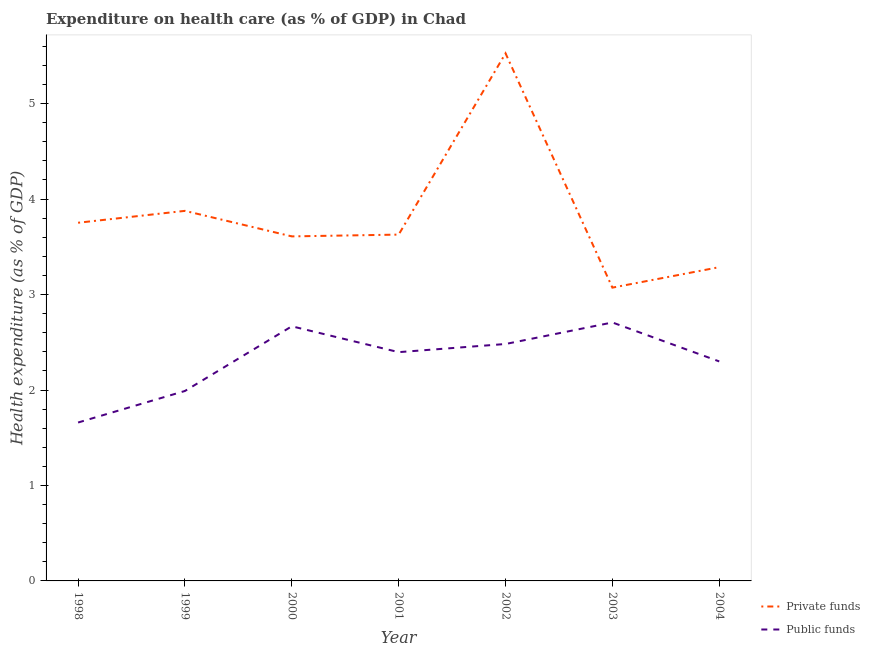Does the line corresponding to amount of private funds spent in healthcare intersect with the line corresponding to amount of public funds spent in healthcare?
Keep it short and to the point. No. What is the amount of private funds spent in healthcare in 2002?
Your response must be concise. 5.53. Across all years, what is the maximum amount of public funds spent in healthcare?
Make the answer very short. 2.71. Across all years, what is the minimum amount of public funds spent in healthcare?
Keep it short and to the point. 1.66. In which year was the amount of public funds spent in healthcare maximum?
Keep it short and to the point. 2003. What is the total amount of private funds spent in healthcare in the graph?
Offer a very short reply. 26.75. What is the difference between the amount of public funds spent in healthcare in 2000 and that in 2002?
Make the answer very short. 0.19. What is the difference between the amount of public funds spent in healthcare in 1999 and the amount of private funds spent in healthcare in 2000?
Your answer should be very brief. -1.62. What is the average amount of public funds spent in healthcare per year?
Your answer should be very brief. 2.31. In the year 1999, what is the difference between the amount of public funds spent in healthcare and amount of private funds spent in healthcare?
Your response must be concise. -1.89. What is the ratio of the amount of public funds spent in healthcare in 1998 to that in 2003?
Keep it short and to the point. 0.61. Is the amount of public funds spent in healthcare in 1999 less than that in 2000?
Your answer should be very brief. Yes. Is the difference between the amount of private funds spent in healthcare in 2002 and 2004 greater than the difference between the amount of public funds spent in healthcare in 2002 and 2004?
Your answer should be very brief. Yes. What is the difference between the highest and the second highest amount of private funds spent in healthcare?
Offer a terse response. 1.65. What is the difference between the highest and the lowest amount of private funds spent in healthcare?
Offer a terse response. 2.45. Is the sum of the amount of private funds spent in healthcare in 1998 and 2002 greater than the maximum amount of public funds spent in healthcare across all years?
Your response must be concise. Yes. Does the amount of public funds spent in healthcare monotonically increase over the years?
Make the answer very short. No. Is the amount of public funds spent in healthcare strictly greater than the amount of private funds spent in healthcare over the years?
Give a very brief answer. No. How many lines are there?
Give a very brief answer. 2. Are the values on the major ticks of Y-axis written in scientific E-notation?
Provide a short and direct response. No. Does the graph contain any zero values?
Provide a short and direct response. No. Does the graph contain grids?
Offer a terse response. No. How many legend labels are there?
Keep it short and to the point. 2. What is the title of the graph?
Offer a very short reply. Expenditure on health care (as % of GDP) in Chad. Does "Not attending school" appear as one of the legend labels in the graph?
Your answer should be compact. No. What is the label or title of the X-axis?
Give a very brief answer. Year. What is the label or title of the Y-axis?
Your answer should be compact. Health expenditure (as % of GDP). What is the Health expenditure (as % of GDP) in Private funds in 1998?
Make the answer very short. 3.75. What is the Health expenditure (as % of GDP) of Public funds in 1998?
Ensure brevity in your answer.  1.66. What is the Health expenditure (as % of GDP) of Private funds in 1999?
Ensure brevity in your answer.  3.88. What is the Health expenditure (as % of GDP) in Public funds in 1999?
Your answer should be compact. 1.99. What is the Health expenditure (as % of GDP) of Private funds in 2000?
Your answer should be compact. 3.61. What is the Health expenditure (as % of GDP) in Public funds in 2000?
Your response must be concise. 2.67. What is the Health expenditure (as % of GDP) in Private funds in 2001?
Keep it short and to the point. 3.63. What is the Health expenditure (as % of GDP) of Public funds in 2001?
Offer a very short reply. 2.4. What is the Health expenditure (as % of GDP) in Private funds in 2002?
Ensure brevity in your answer.  5.53. What is the Health expenditure (as % of GDP) in Public funds in 2002?
Provide a short and direct response. 2.48. What is the Health expenditure (as % of GDP) in Private funds in 2003?
Provide a succinct answer. 3.07. What is the Health expenditure (as % of GDP) in Public funds in 2003?
Make the answer very short. 2.71. What is the Health expenditure (as % of GDP) of Private funds in 2004?
Your response must be concise. 3.29. What is the Health expenditure (as % of GDP) of Public funds in 2004?
Offer a terse response. 2.3. Across all years, what is the maximum Health expenditure (as % of GDP) in Private funds?
Provide a succinct answer. 5.53. Across all years, what is the maximum Health expenditure (as % of GDP) of Public funds?
Your answer should be compact. 2.71. Across all years, what is the minimum Health expenditure (as % of GDP) in Private funds?
Offer a very short reply. 3.07. Across all years, what is the minimum Health expenditure (as % of GDP) of Public funds?
Ensure brevity in your answer.  1.66. What is the total Health expenditure (as % of GDP) of Private funds in the graph?
Provide a short and direct response. 26.75. What is the total Health expenditure (as % of GDP) of Public funds in the graph?
Your answer should be very brief. 16.2. What is the difference between the Health expenditure (as % of GDP) of Private funds in 1998 and that in 1999?
Keep it short and to the point. -0.12. What is the difference between the Health expenditure (as % of GDP) in Public funds in 1998 and that in 1999?
Your answer should be compact. -0.33. What is the difference between the Health expenditure (as % of GDP) of Private funds in 1998 and that in 2000?
Your response must be concise. 0.14. What is the difference between the Health expenditure (as % of GDP) in Public funds in 1998 and that in 2000?
Your answer should be compact. -1.01. What is the difference between the Health expenditure (as % of GDP) of Private funds in 1998 and that in 2001?
Your answer should be compact. 0.12. What is the difference between the Health expenditure (as % of GDP) in Public funds in 1998 and that in 2001?
Provide a succinct answer. -0.74. What is the difference between the Health expenditure (as % of GDP) in Private funds in 1998 and that in 2002?
Provide a succinct answer. -1.77. What is the difference between the Health expenditure (as % of GDP) in Public funds in 1998 and that in 2002?
Ensure brevity in your answer.  -0.82. What is the difference between the Health expenditure (as % of GDP) in Private funds in 1998 and that in 2003?
Make the answer very short. 0.68. What is the difference between the Health expenditure (as % of GDP) in Public funds in 1998 and that in 2003?
Give a very brief answer. -1.05. What is the difference between the Health expenditure (as % of GDP) in Private funds in 1998 and that in 2004?
Ensure brevity in your answer.  0.47. What is the difference between the Health expenditure (as % of GDP) of Public funds in 1998 and that in 2004?
Provide a succinct answer. -0.64. What is the difference between the Health expenditure (as % of GDP) in Private funds in 1999 and that in 2000?
Your answer should be compact. 0.27. What is the difference between the Health expenditure (as % of GDP) of Public funds in 1999 and that in 2000?
Offer a terse response. -0.68. What is the difference between the Health expenditure (as % of GDP) of Private funds in 1999 and that in 2001?
Provide a succinct answer. 0.25. What is the difference between the Health expenditure (as % of GDP) in Public funds in 1999 and that in 2001?
Provide a short and direct response. -0.41. What is the difference between the Health expenditure (as % of GDP) in Private funds in 1999 and that in 2002?
Keep it short and to the point. -1.65. What is the difference between the Health expenditure (as % of GDP) of Public funds in 1999 and that in 2002?
Offer a very short reply. -0.49. What is the difference between the Health expenditure (as % of GDP) of Private funds in 1999 and that in 2003?
Keep it short and to the point. 0.8. What is the difference between the Health expenditure (as % of GDP) of Public funds in 1999 and that in 2003?
Your response must be concise. -0.72. What is the difference between the Health expenditure (as % of GDP) in Private funds in 1999 and that in 2004?
Your answer should be compact. 0.59. What is the difference between the Health expenditure (as % of GDP) of Public funds in 1999 and that in 2004?
Your answer should be very brief. -0.31. What is the difference between the Health expenditure (as % of GDP) of Private funds in 2000 and that in 2001?
Give a very brief answer. -0.02. What is the difference between the Health expenditure (as % of GDP) of Public funds in 2000 and that in 2001?
Your answer should be compact. 0.27. What is the difference between the Health expenditure (as % of GDP) of Private funds in 2000 and that in 2002?
Offer a very short reply. -1.92. What is the difference between the Health expenditure (as % of GDP) of Public funds in 2000 and that in 2002?
Keep it short and to the point. 0.19. What is the difference between the Health expenditure (as % of GDP) in Private funds in 2000 and that in 2003?
Provide a short and direct response. 0.54. What is the difference between the Health expenditure (as % of GDP) in Public funds in 2000 and that in 2003?
Offer a terse response. -0.04. What is the difference between the Health expenditure (as % of GDP) of Private funds in 2000 and that in 2004?
Your answer should be very brief. 0.32. What is the difference between the Health expenditure (as % of GDP) of Public funds in 2000 and that in 2004?
Offer a terse response. 0.37. What is the difference between the Health expenditure (as % of GDP) in Private funds in 2001 and that in 2002?
Give a very brief answer. -1.9. What is the difference between the Health expenditure (as % of GDP) of Public funds in 2001 and that in 2002?
Your answer should be very brief. -0.09. What is the difference between the Health expenditure (as % of GDP) in Private funds in 2001 and that in 2003?
Your response must be concise. 0.56. What is the difference between the Health expenditure (as % of GDP) of Public funds in 2001 and that in 2003?
Keep it short and to the point. -0.31. What is the difference between the Health expenditure (as % of GDP) of Private funds in 2001 and that in 2004?
Keep it short and to the point. 0.34. What is the difference between the Health expenditure (as % of GDP) in Public funds in 2001 and that in 2004?
Your response must be concise. 0.1. What is the difference between the Health expenditure (as % of GDP) in Private funds in 2002 and that in 2003?
Keep it short and to the point. 2.45. What is the difference between the Health expenditure (as % of GDP) in Public funds in 2002 and that in 2003?
Give a very brief answer. -0.23. What is the difference between the Health expenditure (as % of GDP) in Private funds in 2002 and that in 2004?
Ensure brevity in your answer.  2.24. What is the difference between the Health expenditure (as % of GDP) of Public funds in 2002 and that in 2004?
Provide a short and direct response. 0.18. What is the difference between the Health expenditure (as % of GDP) in Private funds in 2003 and that in 2004?
Offer a terse response. -0.21. What is the difference between the Health expenditure (as % of GDP) in Public funds in 2003 and that in 2004?
Offer a terse response. 0.41. What is the difference between the Health expenditure (as % of GDP) of Private funds in 1998 and the Health expenditure (as % of GDP) of Public funds in 1999?
Ensure brevity in your answer.  1.76. What is the difference between the Health expenditure (as % of GDP) in Private funds in 1998 and the Health expenditure (as % of GDP) in Public funds in 2000?
Make the answer very short. 1.08. What is the difference between the Health expenditure (as % of GDP) in Private funds in 1998 and the Health expenditure (as % of GDP) in Public funds in 2001?
Your answer should be very brief. 1.36. What is the difference between the Health expenditure (as % of GDP) in Private funds in 1998 and the Health expenditure (as % of GDP) in Public funds in 2002?
Provide a short and direct response. 1.27. What is the difference between the Health expenditure (as % of GDP) of Private funds in 1998 and the Health expenditure (as % of GDP) of Public funds in 2003?
Your response must be concise. 1.04. What is the difference between the Health expenditure (as % of GDP) of Private funds in 1998 and the Health expenditure (as % of GDP) of Public funds in 2004?
Give a very brief answer. 1.45. What is the difference between the Health expenditure (as % of GDP) in Private funds in 1999 and the Health expenditure (as % of GDP) in Public funds in 2000?
Ensure brevity in your answer.  1.21. What is the difference between the Health expenditure (as % of GDP) of Private funds in 1999 and the Health expenditure (as % of GDP) of Public funds in 2001?
Your answer should be compact. 1.48. What is the difference between the Health expenditure (as % of GDP) of Private funds in 1999 and the Health expenditure (as % of GDP) of Public funds in 2002?
Offer a terse response. 1.39. What is the difference between the Health expenditure (as % of GDP) of Private funds in 1999 and the Health expenditure (as % of GDP) of Public funds in 2003?
Offer a very short reply. 1.17. What is the difference between the Health expenditure (as % of GDP) of Private funds in 1999 and the Health expenditure (as % of GDP) of Public funds in 2004?
Make the answer very short. 1.58. What is the difference between the Health expenditure (as % of GDP) of Private funds in 2000 and the Health expenditure (as % of GDP) of Public funds in 2001?
Ensure brevity in your answer.  1.21. What is the difference between the Health expenditure (as % of GDP) of Private funds in 2000 and the Health expenditure (as % of GDP) of Public funds in 2002?
Make the answer very short. 1.13. What is the difference between the Health expenditure (as % of GDP) of Private funds in 2000 and the Health expenditure (as % of GDP) of Public funds in 2003?
Offer a terse response. 0.9. What is the difference between the Health expenditure (as % of GDP) of Private funds in 2000 and the Health expenditure (as % of GDP) of Public funds in 2004?
Your response must be concise. 1.31. What is the difference between the Health expenditure (as % of GDP) of Private funds in 2001 and the Health expenditure (as % of GDP) of Public funds in 2002?
Your answer should be compact. 1.15. What is the difference between the Health expenditure (as % of GDP) in Private funds in 2001 and the Health expenditure (as % of GDP) in Public funds in 2003?
Provide a succinct answer. 0.92. What is the difference between the Health expenditure (as % of GDP) in Private funds in 2001 and the Health expenditure (as % of GDP) in Public funds in 2004?
Offer a very short reply. 1.33. What is the difference between the Health expenditure (as % of GDP) of Private funds in 2002 and the Health expenditure (as % of GDP) of Public funds in 2003?
Keep it short and to the point. 2.82. What is the difference between the Health expenditure (as % of GDP) of Private funds in 2002 and the Health expenditure (as % of GDP) of Public funds in 2004?
Your answer should be very brief. 3.23. What is the difference between the Health expenditure (as % of GDP) of Private funds in 2003 and the Health expenditure (as % of GDP) of Public funds in 2004?
Ensure brevity in your answer.  0.77. What is the average Health expenditure (as % of GDP) of Private funds per year?
Give a very brief answer. 3.82. What is the average Health expenditure (as % of GDP) in Public funds per year?
Keep it short and to the point. 2.31. In the year 1998, what is the difference between the Health expenditure (as % of GDP) in Private funds and Health expenditure (as % of GDP) in Public funds?
Your answer should be very brief. 2.09. In the year 1999, what is the difference between the Health expenditure (as % of GDP) in Private funds and Health expenditure (as % of GDP) in Public funds?
Your answer should be very brief. 1.89. In the year 2000, what is the difference between the Health expenditure (as % of GDP) in Private funds and Health expenditure (as % of GDP) in Public funds?
Offer a terse response. 0.94. In the year 2001, what is the difference between the Health expenditure (as % of GDP) of Private funds and Health expenditure (as % of GDP) of Public funds?
Give a very brief answer. 1.23. In the year 2002, what is the difference between the Health expenditure (as % of GDP) in Private funds and Health expenditure (as % of GDP) in Public funds?
Ensure brevity in your answer.  3.04. In the year 2003, what is the difference between the Health expenditure (as % of GDP) of Private funds and Health expenditure (as % of GDP) of Public funds?
Give a very brief answer. 0.36. In the year 2004, what is the difference between the Health expenditure (as % of GDP) of Private funds and Health expenditure (as % of GDP) of Public funds?
Your answer should be compact. 0.99. What is the ratio of the Health expenditure (as % of GDP) of Private funds in 1998 to that in 1999?
Your answer should be compact. 0.97. What is the ratio of the Health expenditure (as % of GDP) of Public funds in 1998 to that in 1999?
Your response must be concise. 0.83. What is the ratio of the Health expenditure (as % of GDP) in Private funds in 1998 to that in 2000?
Offer a very short reply. 1.04. What is the ratio of the Health expenditure (as % of GDP) of Public funds in 1998 to that in 2000?
Your answer should be compact. 0.62. What is the ratio of the Health expenditure (as % of GDP) of Private funds in 1998 to that in 2001?
Provide a short and direct response. 1.03. What is the ratio of the Health expenditure (as % of GDP) in Public funds in 1998 to that in 2001?
Offer a very short reply. 0.69. What is the ratio of the Health expenditure (as % of GDP) in Private funds in 1998 to that in 2002?
Give a very brief answer. 0.68. What is the ratio of the Health expenditure (as % of GDP) in Public funds in 1998 to that in 2002?
Make the answer very short. 0.67. What is the ratio of the Health expenditure (as % of GDP) in Private funds in 1998 to that in 2003?
Make the answer very short. 1.22. What is the ratio of the Health expenditure (as % of GDP) in Public funds in 1998 to that in 2003?
Provide a short and direct response. 0.61. What is the ratio of the Health expenditure (as % of GDP) of Private funds in 1998 to that in 2004?
Your response must be concise. 1.14. What is the ratio of the Health expenditure (as % of GDP) of Public funds in 1998 to that in 2004?
Provide a succinct answer. 0.72. What is the ratio of the Health expenditure (as % of GDP) of Private funds in 1999 to that in 2000?
Your response must be concise. 1.07. What is the ratio of the Health expenditure (as % of GDP) in Public funds in 1999 to that in 2000?
Your answer should be compact. 0.75. What is the ratio of the Health expenditure (as % of GDP) in Private funds in 1999 to that in 2001?
Your answer should be very brief. 1.07. What is the ratio of the Health expenditure (as % of GDP) in Public funds in 1999 to that in 2001?
Make the answer very short. 0.83. What is the ratio of the Health expenditure (as % of GDP) of Private funds in 1999 to that in 2002?
Your response must be concise. 0.7. What is the ratio of the Health expenditure (as % of GDP) of Public funds in 1999 to that in 2002?
Your answer should be compact. 0.8. What is the ratio of the Health expenditure (as % of GDP) of Private funds in 1999 to that in 2003?
Ensure brevity in your answer.  1.26. What is the ratio of the Health expenditure (as % of GDP) in Public funds in 1999 to that in 2003?
Your response must be concise. 0.73. What is the ratio of the Health expenditure (as % of GDP) in Private funds in 1999 to that in 2004?
Provide a short and direct response. 1.18. What is the ratio of the Health expenditure (as % of GDP) in Public funds in 1999 to that in 2004?
Offer a terse response. 0.87. What is the ratio of the Health expenditure (as % of GDP) of Private funds in 2000 to that in 2001?
Provide a short and direct response. 0.99. What is the ratio of the Health expenditure (as % of GDP) in Public funds in 2000 to that in 2001?
Your answer should be very brief. 1.11. What is the ratio of the Health expenditure (as % of GDP) of Private funds in 2000 to that in 2002?
Keep it short and to the point. 0.65. What is the ratio of the Health expenditure (as % of GDP) of Public funds in 2000 to that in 2002?
Ensure brevity in your answer.  1.07. What is the ratio of the Health expenditure (as % of GDP) of Private funds in 2000 to that in 2003?
Offer a terse response. 1.17. What is the ratio of the Health expenditure (as % of GDP) in Public funds in 2000 to that in 2003?
Your answer should be very brief. 0.99. What is the ratio of the Health expenditure (as % of GDP) of Private funds in 2000 to that in 2004?
Give a very brief answer. 1.1. What is the ratio of the Health expenditure (as % of GDP) in Public funds in 2000 to that in 2004?
Your response must be concise. 1.16. What is the ratio of the Health expenditure (as % of GDP) in Private funds in 2001 to that in 2002?
Your response must be concise. 0.66. What is the ratio of the Health expenditure (as % of GDP) in Public funds in 2001 to that in 2002?
Offer a terse response. 0.97. What is the ratio of the Health expenditure (as % of GDP) in Private funds in 2001 to that in 2003?
Give a very brief answer. 1.18. What is the ratio of the Health expenditure (as % of GDP) in Public funds in 2001 to that in 2003?
Give a very brief answer. 0.89. What is the ratio of the Health expenditure (as % of GDP) of Private funds in 2001 to that in 2004?
Offer a terse response. 1.1. What is the ratio of the Health expenditure (as % of GDP) in Public funds in 2001 to that in 2004?
Your answer should be very brief. 1.04. What is the ratio of the Health expenditure (as % of GDP) of Private funds in 2002 to that in 2003?
Give a very brief answer. 1.8. What is the ratio of the Health expenditure (as % of GDP) in Public funds in 2002 to that in 2003?
Your response must be concise. 0.92. What is the ratio of the Health expenditure (as % of GDP) in Private funds in 2002 to that in 2004?
Offer a terse response. 1.68. What is the ratio of the Health expenditure (as % of GDP) of Public funds in 2002 to that in 2004?
Your answer should be compact. 1.08. What is the ratio of the Health expenditure (as % of GDP) in Private funds in 2003 to that in 2004?
Your answer should be compact. 0.93. What is the ratio of the Health expenditure (as % of GDP) of Public funds in 2003 to that in 2004?
Offer a very short reply. 1.18. What is the difference between the highest and the second highest Health expenditure (as % of GDP) of Private funds?
Keep it short and to the point. 1.65. What is the difference between the highest and the second highest Health expenditure (as % of GDP) in Public funds?
Offer a terse response. 0.04. What is the difference between the highest and the lowest Health expenditure (as % of GDP) of Private funds?
Give a very brief answer. 2.45. What is the difference between the highest and the lowest Health expenditure (as % of GDP) in Public funds?
Your response must be concise. 1.05. 